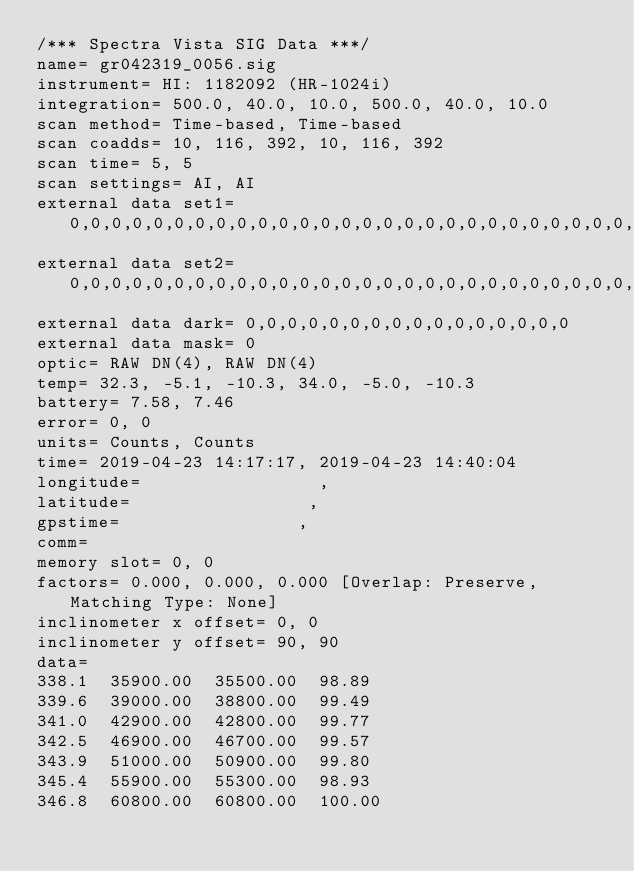Convert code to text. <code><loc_0><loc_0><loc_500><loc_500><_SML_>/*** Spectra Vista SIG Data ***/
name= gr042319_0056.sig
instrument= HI: 1182092 (HR-1024i)
integration= 500.0, 40.0, 10.0, 500.0, 40.0, 10.0
scan method= Time-based, Time-based
scan coadds= 10, 116, 392, 10, 116, 392
scan time= 5, 5
scan settings= AI, AI
external data set1= 0,0,0,0,0,0,0,0,0,0,0,0,0,0,0,0,0,0,0,0,0,0,0,0,0,0,0,0,0,0,0,0
external data set2= 0,0,0,0,0,0,0,0,0,0,0,0,0,0,0,0,0,0,0,0,0,0,0,0,0,0,0,0,0,0,0,0
external data dark= 0,0,0,0,0,0,0,0,0,0,0,0,0,0,0,0
external data mask= 0
optic= RAW DN(4), RAW DN(4)
temp= 32.3, -5.1, -10.3, 34.0, -5.0, -10.3
battery= 7.58, 7.46
error= 0, 0
units= Counts, Counts
time= 2019-04-23 14:17:17, 2019-04-23 14:40:04
longitude=                 ,                 
latitude=                 ,                 
gpstime=                 ,                 
comm= 
memory slot= 0, 0
factors= 0.000, 0.000, 0.000 [Overlap: Preserve, Matching Type: None]
inclinometer x offset= 0, 0
inclinometer y offset= 90, 90
data= 
338.1  35900.00  35500.00  98.89
339.6  39000.00  38800.00  99.49
341.0  42900.00  42800.00  99.77
342.5  46900.00  46700.00  99.57
343.9  51000.00  50900.00  99.80
345.4  55900.00  55300.00  98.93
346.8  60800.00  60800.00  100.00</code> 